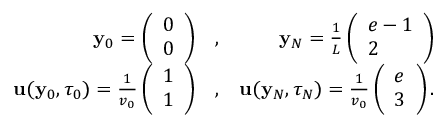<formula> <loc_0><loc_0><loc_500><loc_500>\begin{array} { r l r } { { \mathbf y } _ { 0 } = \left ( \begin{array} { l } { 0 } \\ { 0 } \end{array} \right ) } & { , } & { { \mathbf y } _ { N } = \frac { 1 } { L } \left ( \begin{array} { l } { e - 1 } \\ { 2 } \end{array} \right ) } \\ { { \mathbf u } ( { \mathbf y } _ { 0 } , \tau _ { 0 } ) = \frac { 1 } { v _ { 0 } } \left ( \begin{array} { l } { 1 } \\ { 1 } \end{array} \right ) } & { , } & { { \mathbf u } ( { \mathbf y } _ { N } , \tau _ { N } ) = \frac { 1 } { v _ { 0 } } \left ( \begin{array} { l } { e } \\ { 3 } \end{array} \right ) . } \end{array}</formula> 